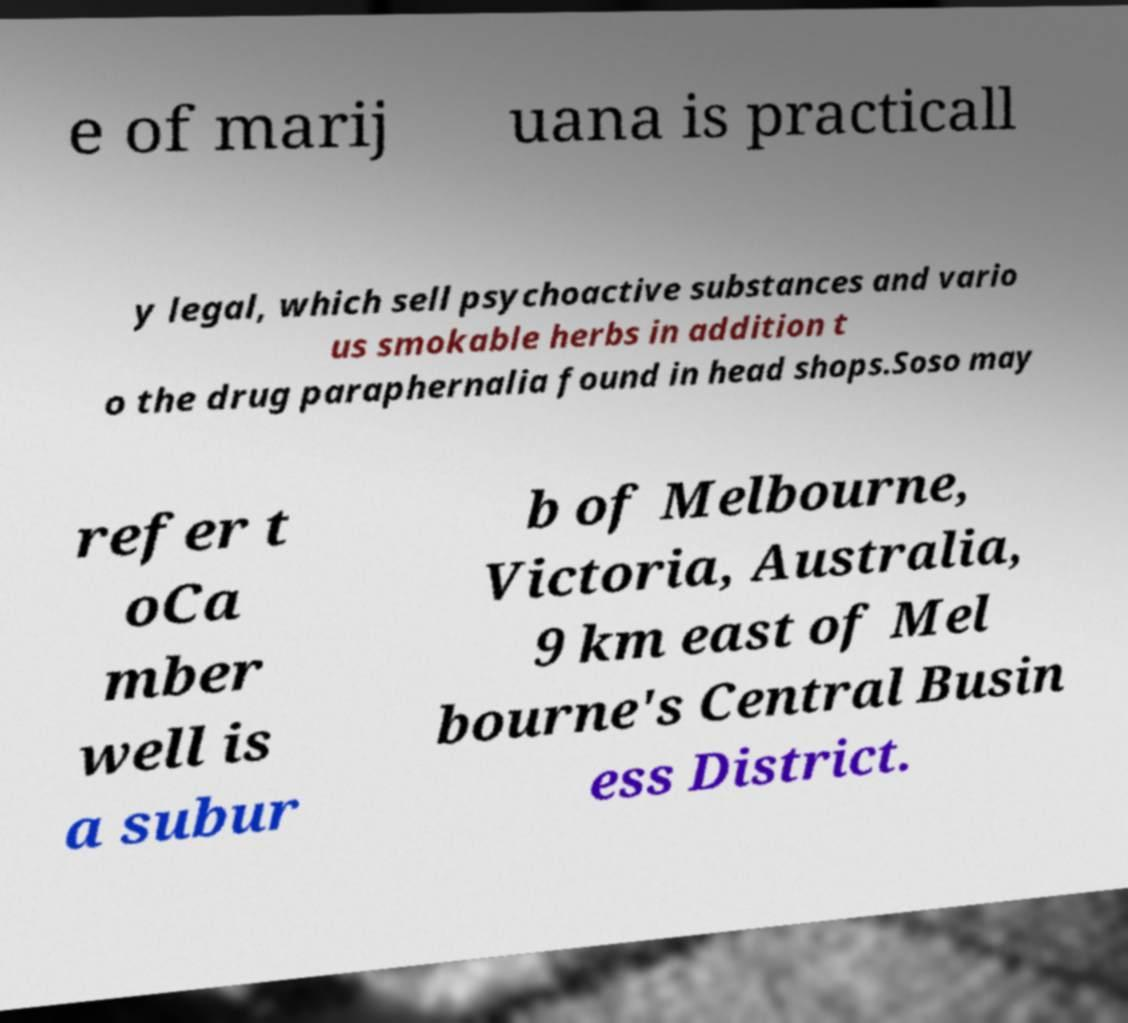Can you accurately transcribe the text from the provided image for me? e of marij uana is practicall y legal, which sell psychoactive substances and vario us smokable herbs in addition t o the drug paraphernalia found in head shops.Soso may refer t oCa mber well is a subur b of Melbourne, Victoria, Australia, 9 km east of Mel bourne's Central Busin ess District. 